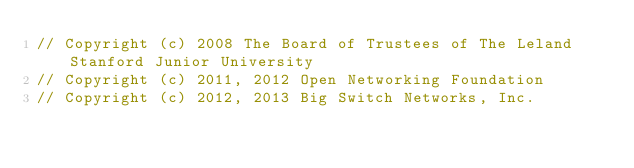Convert code to text. <code><loc_0><loc_0><loc_500><loc_500><_Java_>// Copyright (c) 2008 The Board of Trustees of The Leland Stanford Junior University
// Copyright (c) 2011, 2012 Open Networking Foundation
// Copyright (c) 2012, 2013 Big Switch Networks, Inc.</code> 